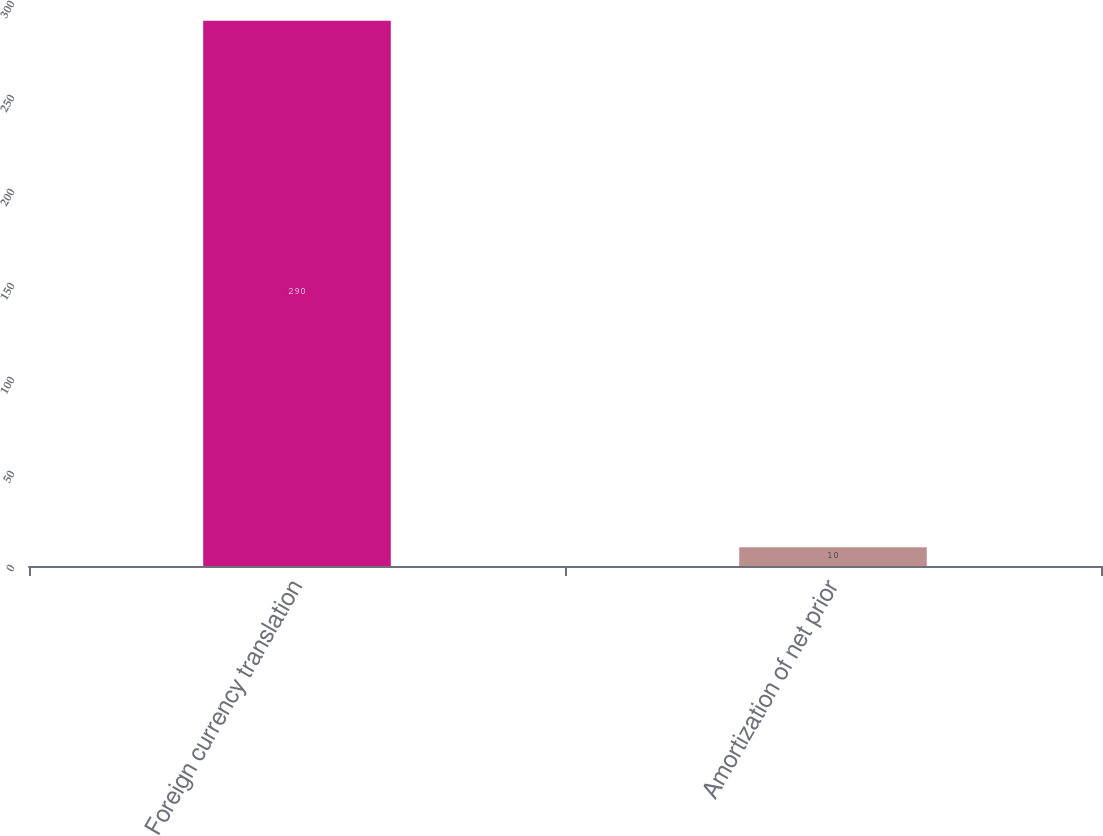<chart> <loc_0><loc_0><loc_500><loc_500><bar_chart><fcel>Foreign currency translation<fcel>Amortization of net prior<nl><fcel>290<fcel>10<nl></chart> 